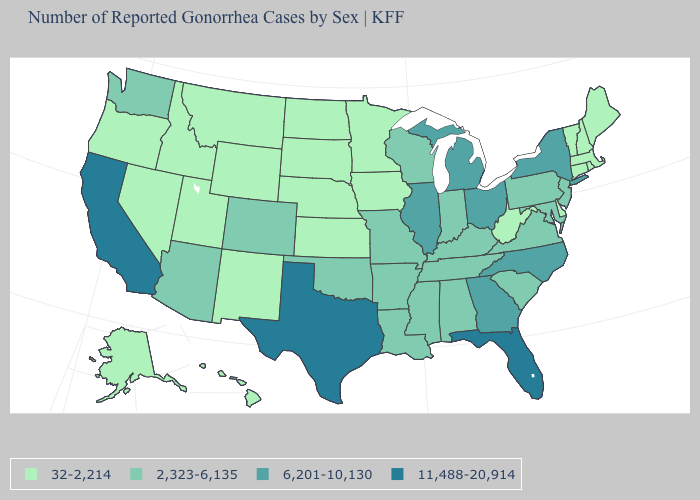Which states have the highest value in the USA?
Short answer required. California, Florida, Texas. What is the value of Illinois?
Concise answer only. 6,201-10,130. Which states have the lowest value in the MidWest?
Keep it brief. Iowa, Kansas, Minnesota, Nebraska, North Dakota, South Dakota. What is the value of Washington?
Concise answer only. 2,323-6,135. What is the value of Louisiana?
Quick response, please. 2,323-6,135. What is the value of Missouri?
Quick response, please. 2,323-6,135. Name the states that have a value in the range 6,201-10,130?
Keep it brief. Georgia, Illinois, Michigan, New York, North Carolina, Ohio. Does California have the highest value in the USA?
Give a very brief answer. Yes. Name the states that have a value in the range 11,488-20,914?
Keep it brief. California, Florida, Texas. Name the states that have a value in the range 2,323-6,135?
Concise answer only. Alabama, Arizona, Arkansas, Colorado, Indiana, Kentucky, Louisiana, Maryland, Mississippi, Missouri, New Jersey, Oklahoma, Pennsylvania, South Carolina, Tennessee, Virginia, Washington, Wisconsin. How many symbols are there in the legend?
Short answer required. 4. What is the highest value in states that border Alabama?
Short answer required. 11,488-20,914. Which states have the highest value in the USA?
Short answer required. California, Florida, Texas. Among the states that border Nebraska , which have the lowest value?
Answer briefly. Iowa, Kansas, South Dakota, Wyoming. Does the first symbol in the legend represent the smallest category?
Be succinct. Yes. 